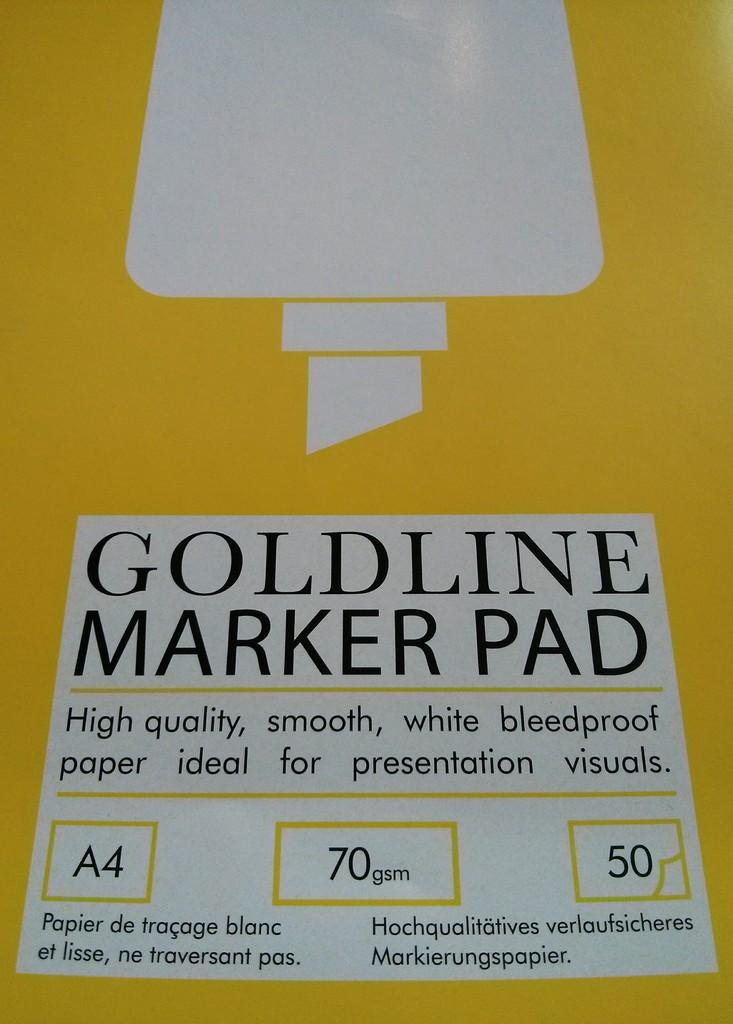<image>
Write a terse but informative summary of the picture. A pad for presentation from Goldline stating it is high quality and smooth which will be ideal for presentations. 